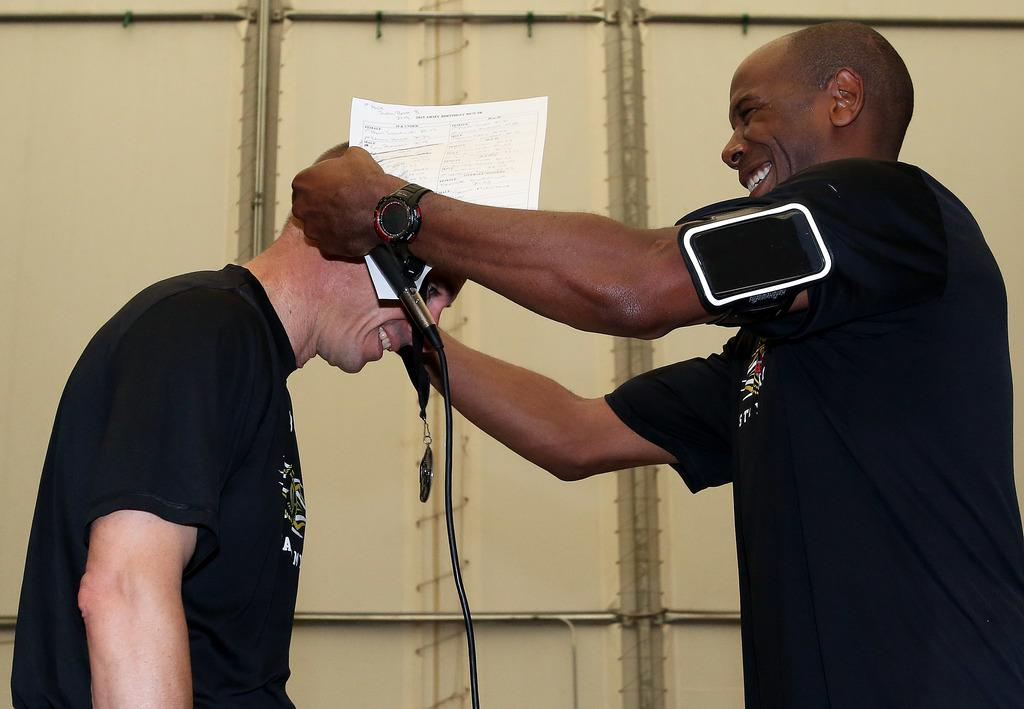How many people are in the image? There are two men in the image. What are the men doing in the image? Both men are standing. What is one of the men holding in his hand? One of the men is holding a mic in his hand. What else is the man with the mic holding? The man with the mic is also holding a paper. What type of war is depicted in the image? There is no war depicted in the image; it features two men, one of whom is holding a mic and a paper. What kind of jewel can be seen on the zebra in the image? There is no zebra present in the image, and therefore no jewel can be seen. 